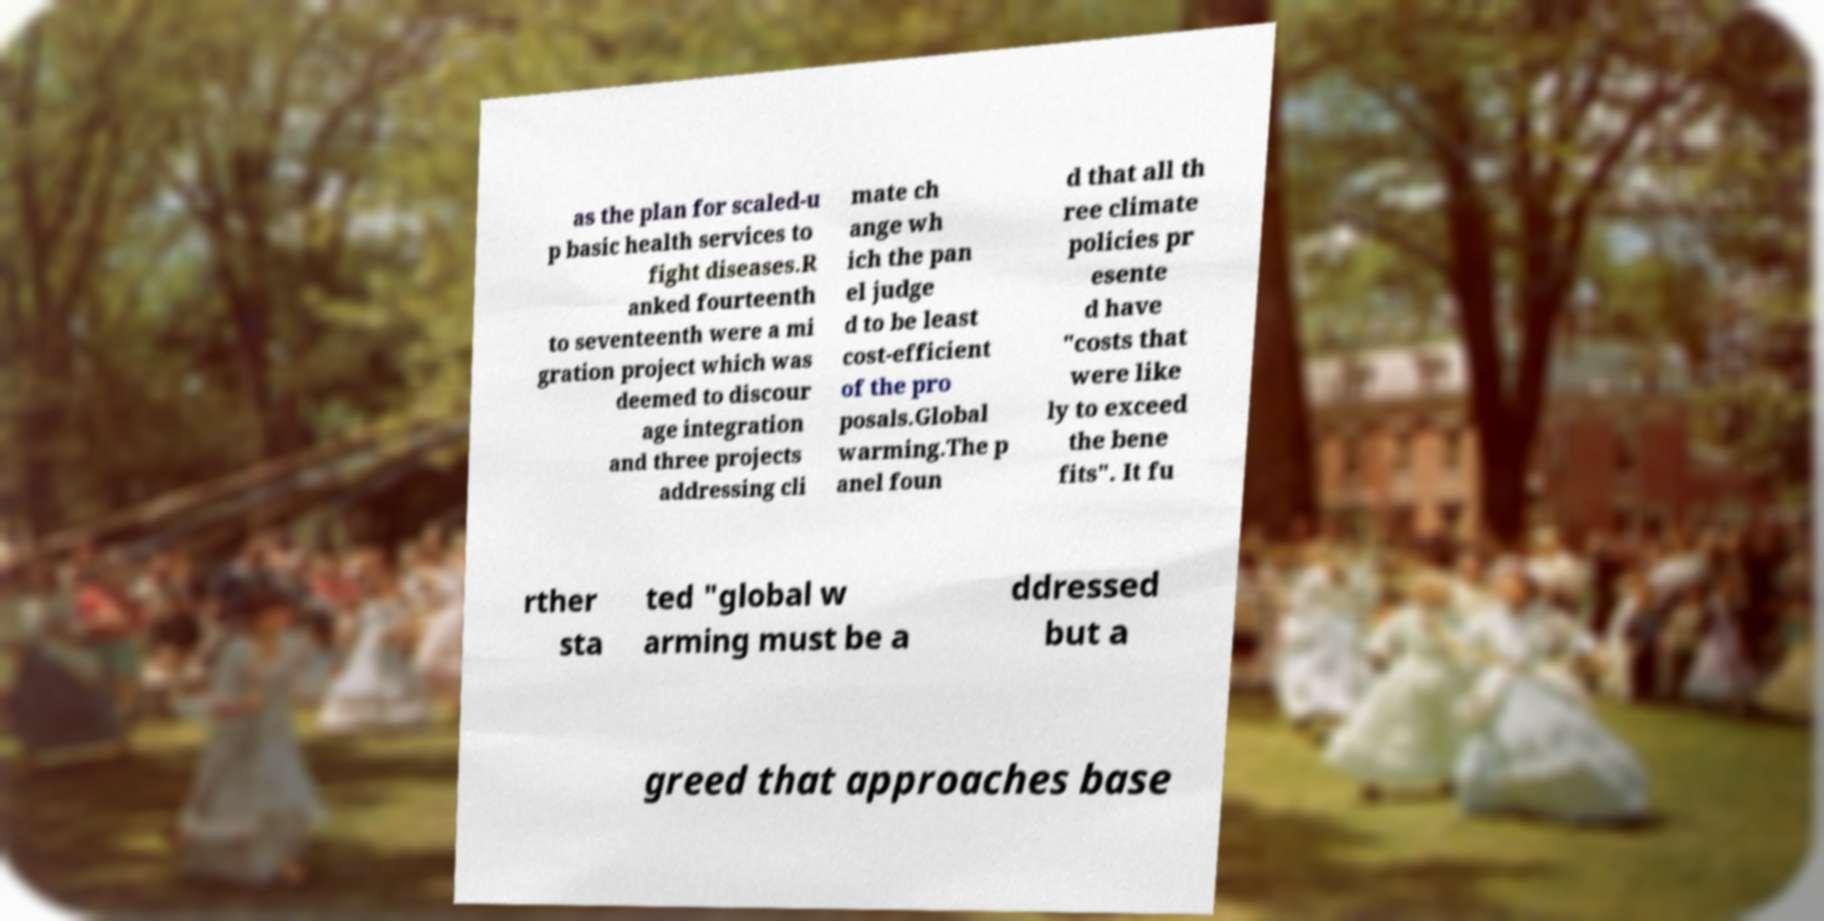Could you extract and type out the text from this image? as the plan for scaled-u p basic health services to fight diseases.R anked fourteenth to seventeenth were a mi gration project which was deemed to discour age integration and three projects addressing cli mate ch ange wh ich the pan el judge d to be least cost-efficient of the pro posals.Global warming.The p anel foun d that all th ree climate policies pr esente d have "costs that were like ly to exceed the bene fits". It fu rther sta ted "global w arming must be a ddressed but a greed that approaches base 